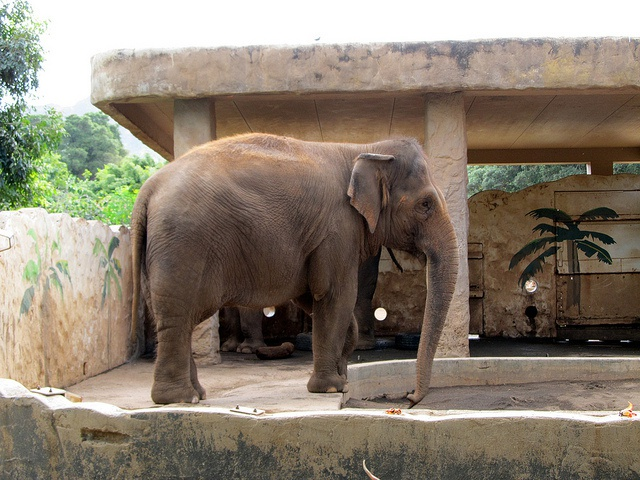Describe the objects in this image and their specific colors. I can see a elephant in lightgray, gray, black, and maroon tones in this image. 